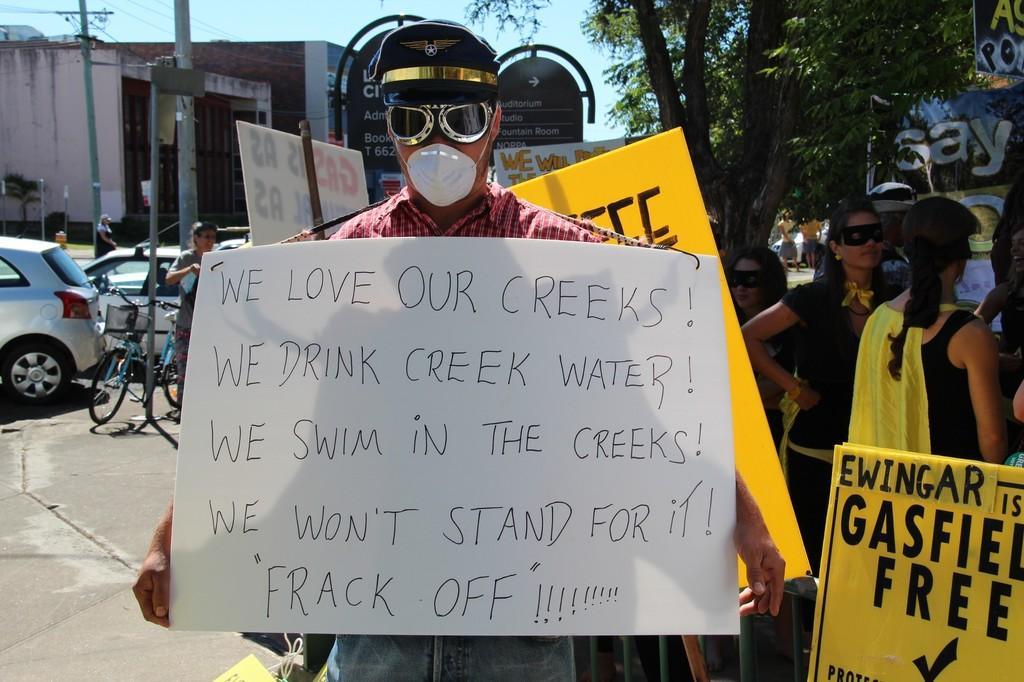Please provide a concise description of this image. In this image we can see a man standing on the road. He is wearing a shirt and he is holding a notice board. Here we can see a cap on his head. Here we can see a few persons on the right side. Here we can see the trees on the right side. Here we can see the cars on the road and they are on they are on the left side. Here we can see a bicycle. Here we can see the buildings on the left side. 